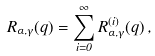Convert formula to latex. <formula><loc_0><loc_0><loc_500><loc_500>R _ { \alpha , \gamma } ( q ) = \sum _ { i = 0 } ^ { \infty } R _ { \alpha , \gamma } ^ { ( i ) } ( q ) \, ,</formula> 